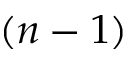<formula> <loc_0><loc_0><loc_500><loc_500>( n - 1 )</formula> 